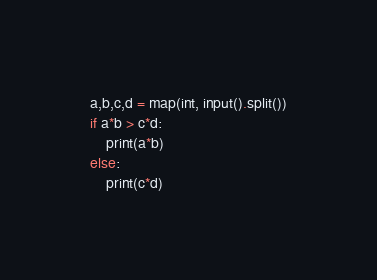<code> <loc_0><loc_0><loc_500><loc_500><_Python_>a,b,c,d = map(int, input().split())
if a*b > c*d:
    print(a*b)
else:
    print(c*d)</code> 